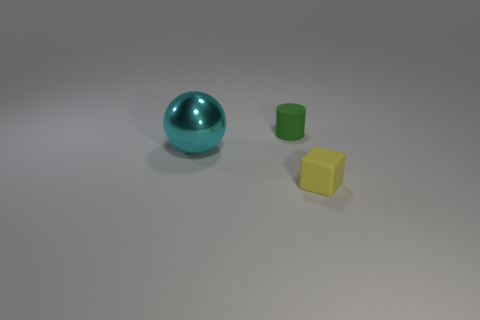Add 1 small green cylinders. How many objects exist? 4 Subtract all blocks. How many objects are left? 2 Add 2 green cylinders. How many green cylinders exist? 3 Subtract 0 yellow cylinders. How many objects are left? 3 Subtract all blue balls. Subtract all red cylinders. How many balls are left? 1 Subtract all red spheres. How many brown cylinders are left? 0 Subtract all large gray spheres. Subtract all small rubber cubes. How many objects are left? 2 Add 2 large cyan metal objects. How many large cyan metal objects are left? 3 